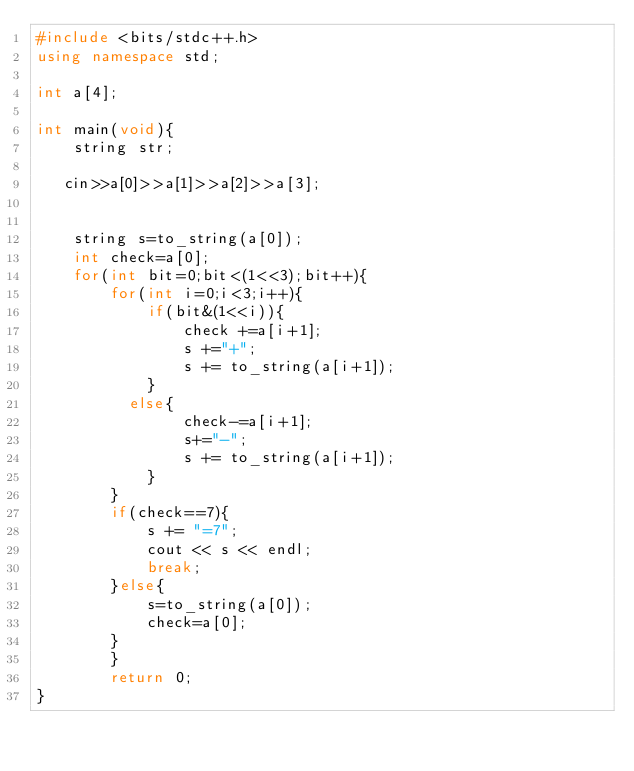Convert code to text. <code><loc_0><loc_0><loc_500><loc_500><_C++_>#include <bits/stdc++.h>
using namespace std;

int a[4];

int main(void){
    string str;

   cin>>a[0]>>a[1]>>a[2]>>a[3];
  
  
    string s=to_string(a[0]);
    int check=a[0];
    for(int bit=0;bit<(1<<3);bit++){
        for(int i=0;i<3;i++){
            if(bit&(1<<i)){
                check +=a[i+1];
                s +="+";
                s += to_string(a[i+1]);
            }
          else{
                check-=a[i+1];
                s+="-";
                s += to_string(a[i+1]);
            }
        }
        if(check==7){
            s += "=7";
            cout << s << endl;
            break;
        }else{
            s=to_string(a[0]);
            check=a[0];
        }
        }
        return 0;
}
</code> 